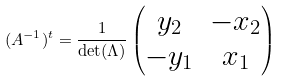<formula> <loc_0><loc_0><loc_500><loc_500>( A ^ { - 1 } ) ^ { t } = \frac { 1 } { \det ( \Lambda ) } \left ( \begin{matrix} y _ { 2 } & - x _ { 2 } \\ - y _ { 1 } & x _ { 1 } \end{matrix} \right )</formula> 